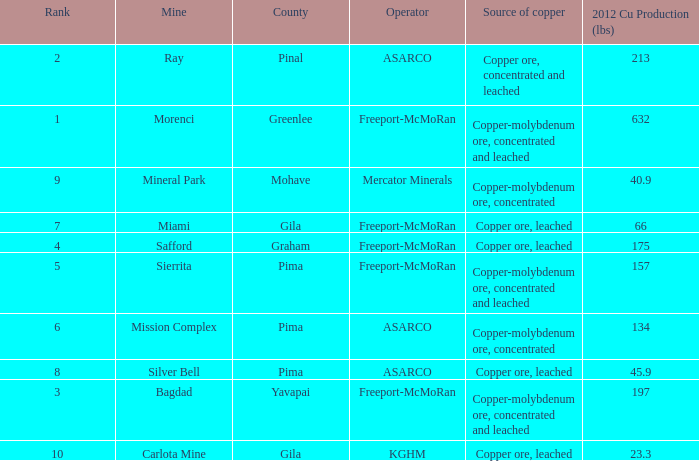What's the lowest ranking source of copper, copper ore, concentrated and leached? 2.0. 